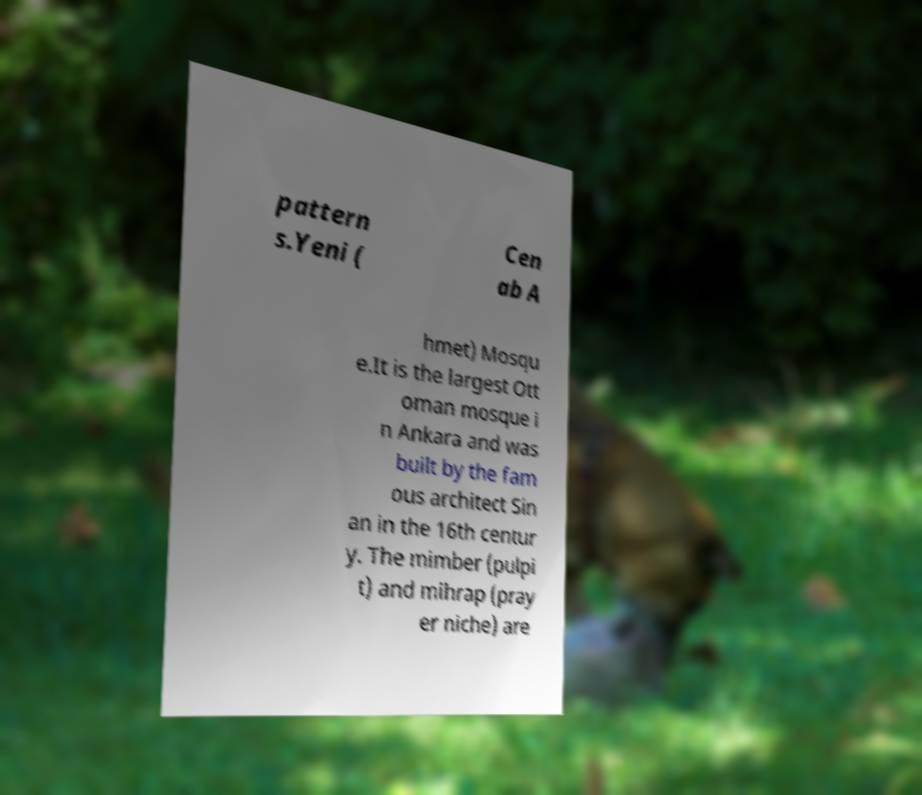There's text embedded in this image that I need extracted. Can you transcribe it verbatim? pattern s.Yeni ( Cen ab A hmet) Mosqu e.It is the largest Ott oman mosque i n Ankara and was built by the fam ous architect Sin an in the 16th centur y. The mimber (pulpi t) and mihrap (pray er niche) are 